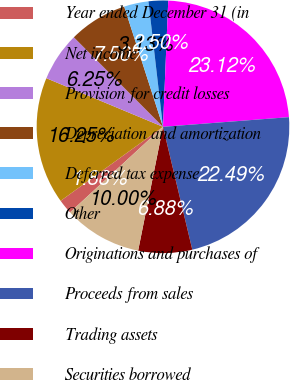<chart> <loc_0><loc_0><loc_500><loc_500><pie_chart><fcel>Year ended December 31 (in<fcel>Net income<fcel>Provision for credit losses<fcel>Depreciation and amortization<fcel>Deferred tax expense<fcel>Other<fcel>Originations and purchases of<fcel>Proceeds from sales<fcel>Trading assets<fcel>Securities borrowed<nl><fcel>1.88%<fcel>16.25%<fcel>6.25%<fcel>7.5%<fcel>3.13%<fcel>2.5%<fcel>23.12%<fcel>22.49%<fcel>6.88%<fcel>10.0%<nl></chart> 